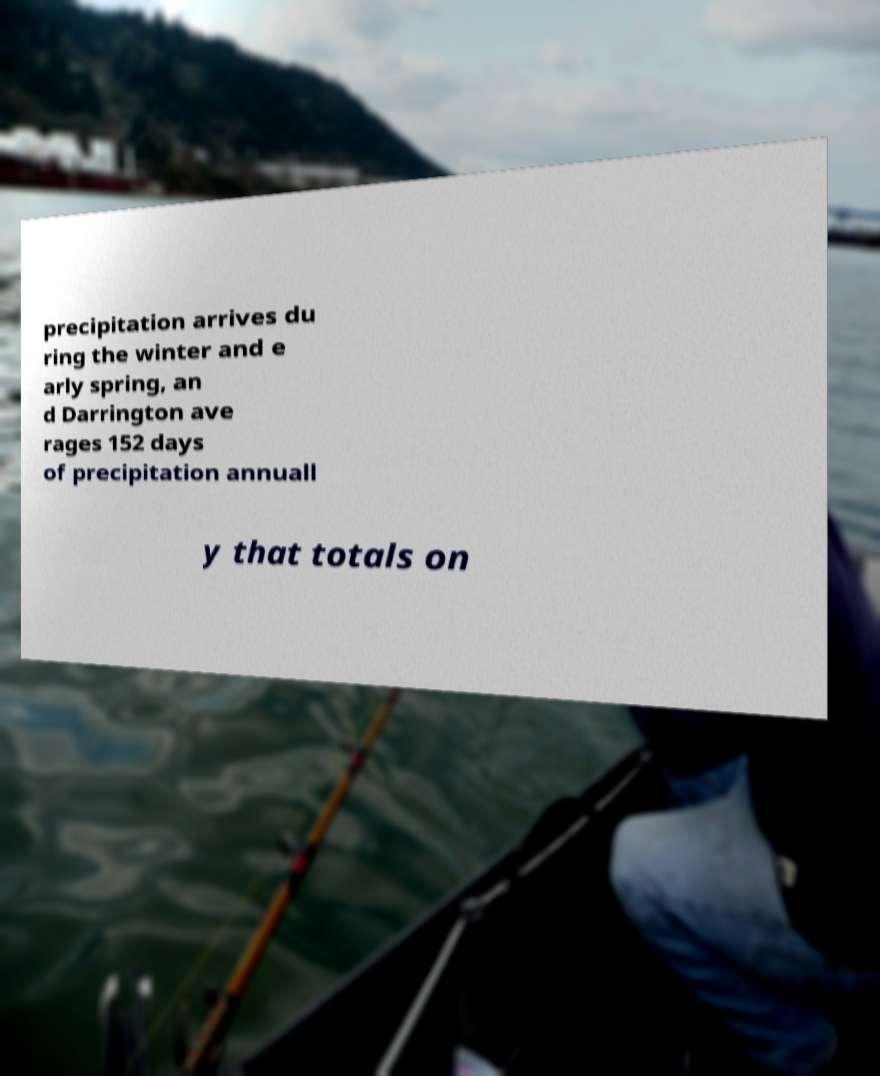Could you extract and type out the text from this image? precipitation arrives du ring the winter and e arly spring, an d Darrington ave rages 152 days of precipitation annuall y that totals on 